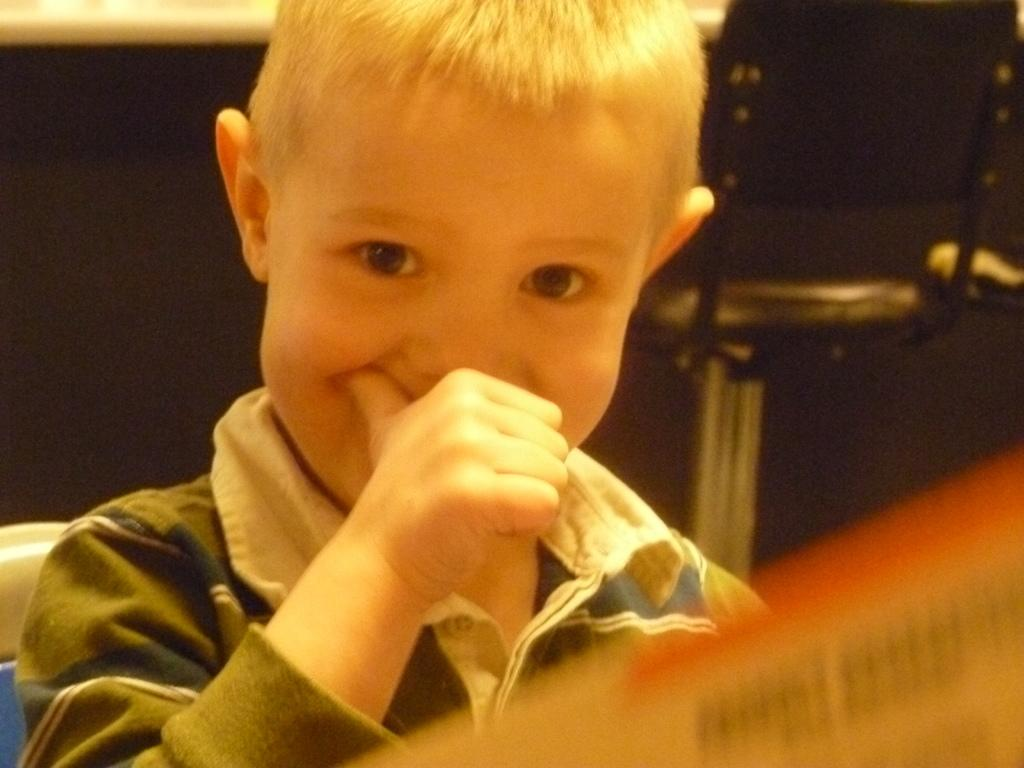Who is the main subject in the picture? There is a boy in the picture. Can you describe the background of the image? The background of the image is blurred. What type of pencil is the boy holding in the image? There is no pencil visible in the image. What kind of shoes is the boy wearing in the image? The image does not show the boy's shoes. 